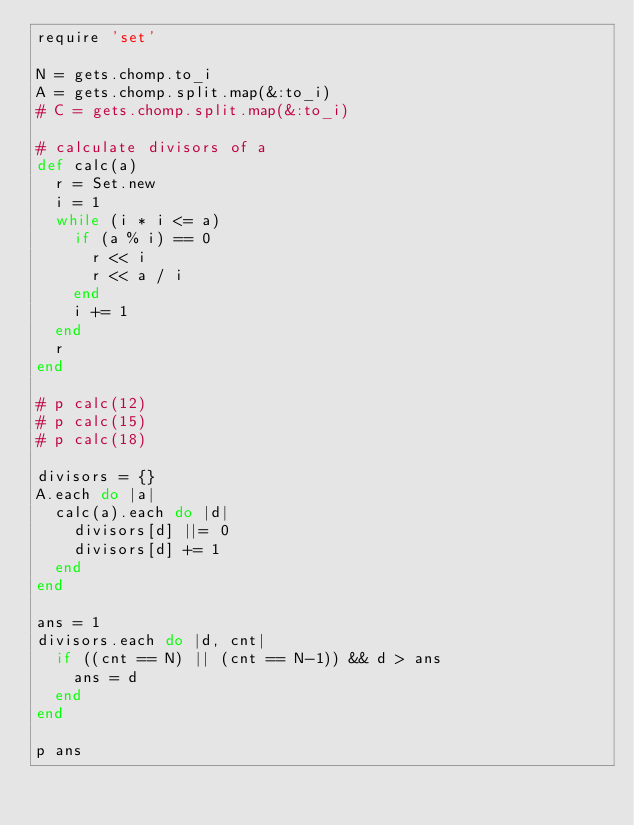<code> <loc_0><loc_0><loc_500><loc_500><_Ruby_>require 'set'

N = gets.chomp.to_i
A = gets.chomp.split.map(&:to_i)
# C = gets.chomp.split.map(&:to_i)

# calculate divisors of a
def calc(a)
  r = Set.new
  i = 1
  while (i * i <= a) 
    if (a % i) == 0
      r << i
      r << a / i
    end
    i += 1
  end
  r
end

# p calc(12)
# p calc(15)
# p calc(18)

divisors = {}
A.each do |a|
  calc(a).each do |d|
    divisors[d] ||= 0
    divisors[d] += 1
  end
end

ans = 1
divisors.each do |d, cnt|
  if ((cnt == N) || (cnt == N-1)) && d > ans
    ans = d
  end
end

p ans</code> 